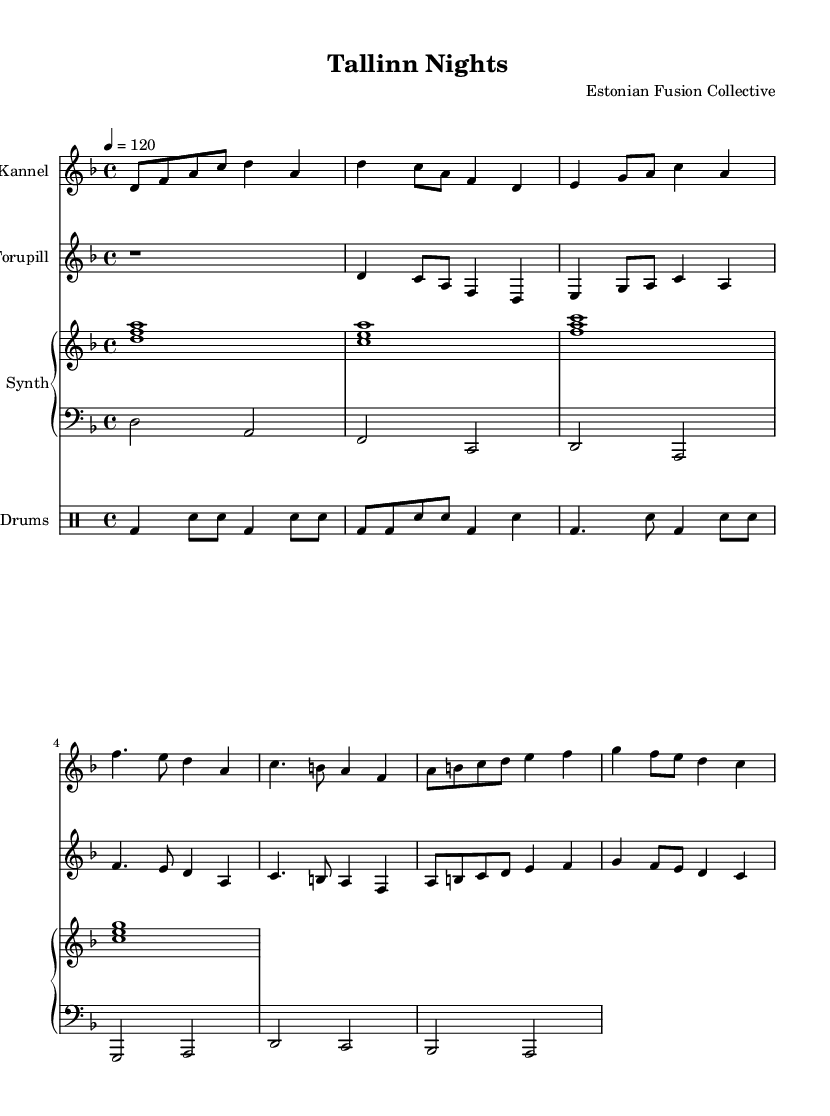What is the key signature of this music? The key signature is D minor, which has one flat (B♭). It can be identified at the beginning of the staff where the B♭ sign is placed.
Answer: D minor What is the time signature of this music? The time signature is 4/4, which indicates that there are four beats in each measure. This can be found under the clef at the start of the score.
Answer: 4/4 What is the tempo marking for this piece? The tempo marking is quarter note equals 120. This is indicated above the staff, providing the speed at which the piece should be played.
Answer: 120 How many measures are there in the kannel part? The kannel part consists of six measures. By counting the vertical lines that separate the measures in the kannel staff, we find there are a total of six.
Answer: 6 Which traditional instrument is featured prominently in this score? The traditional instrument featured prominently is the Kannel. It is indicated as the first staff and is a traditional Estonian string instrument.
Answer: Kannel What type of synthesizers are used in this piece? The synthesizers used are categorized into upper and lower parts. The upper part consists of chords, and the lower part consists of bass notes, which can be identified in the piano staff that is labeled "Synth."
Answer: Electronic synths What rhythmic pattern is used in the drum part? The drum part incorporates a basic pattern combining bass drum (bd) and snare (sn) notes, alternating primarily between quarter notes and eighth notes. The drum line can be identified in the notated rhythm that uses drum notation.
Answer: Alternating bass and snare 